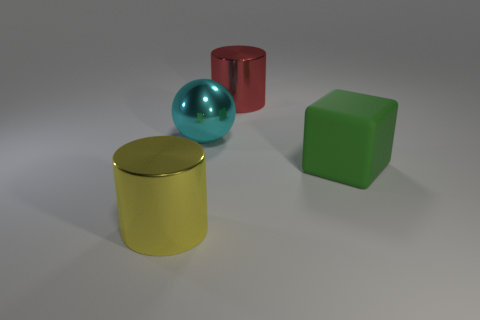Subtract all brown cubes. Subtract all green spheres. How many cubes are left? 1 Add 4 tiny purple blocks. How many objects exist? 8 Subtract all spheres. How many objects are left? 3 Subtract 0 cyan cylinders. How many objects are left? 4 Subtract all tiny cyan matte cylinders. Subtract all yellow cylinders. How many objects are left? 3 Add 2 rubber objects. How many rubber objects are left? 3 Add 1 red matte cylinders. How many red matte cylinders exist? 1 